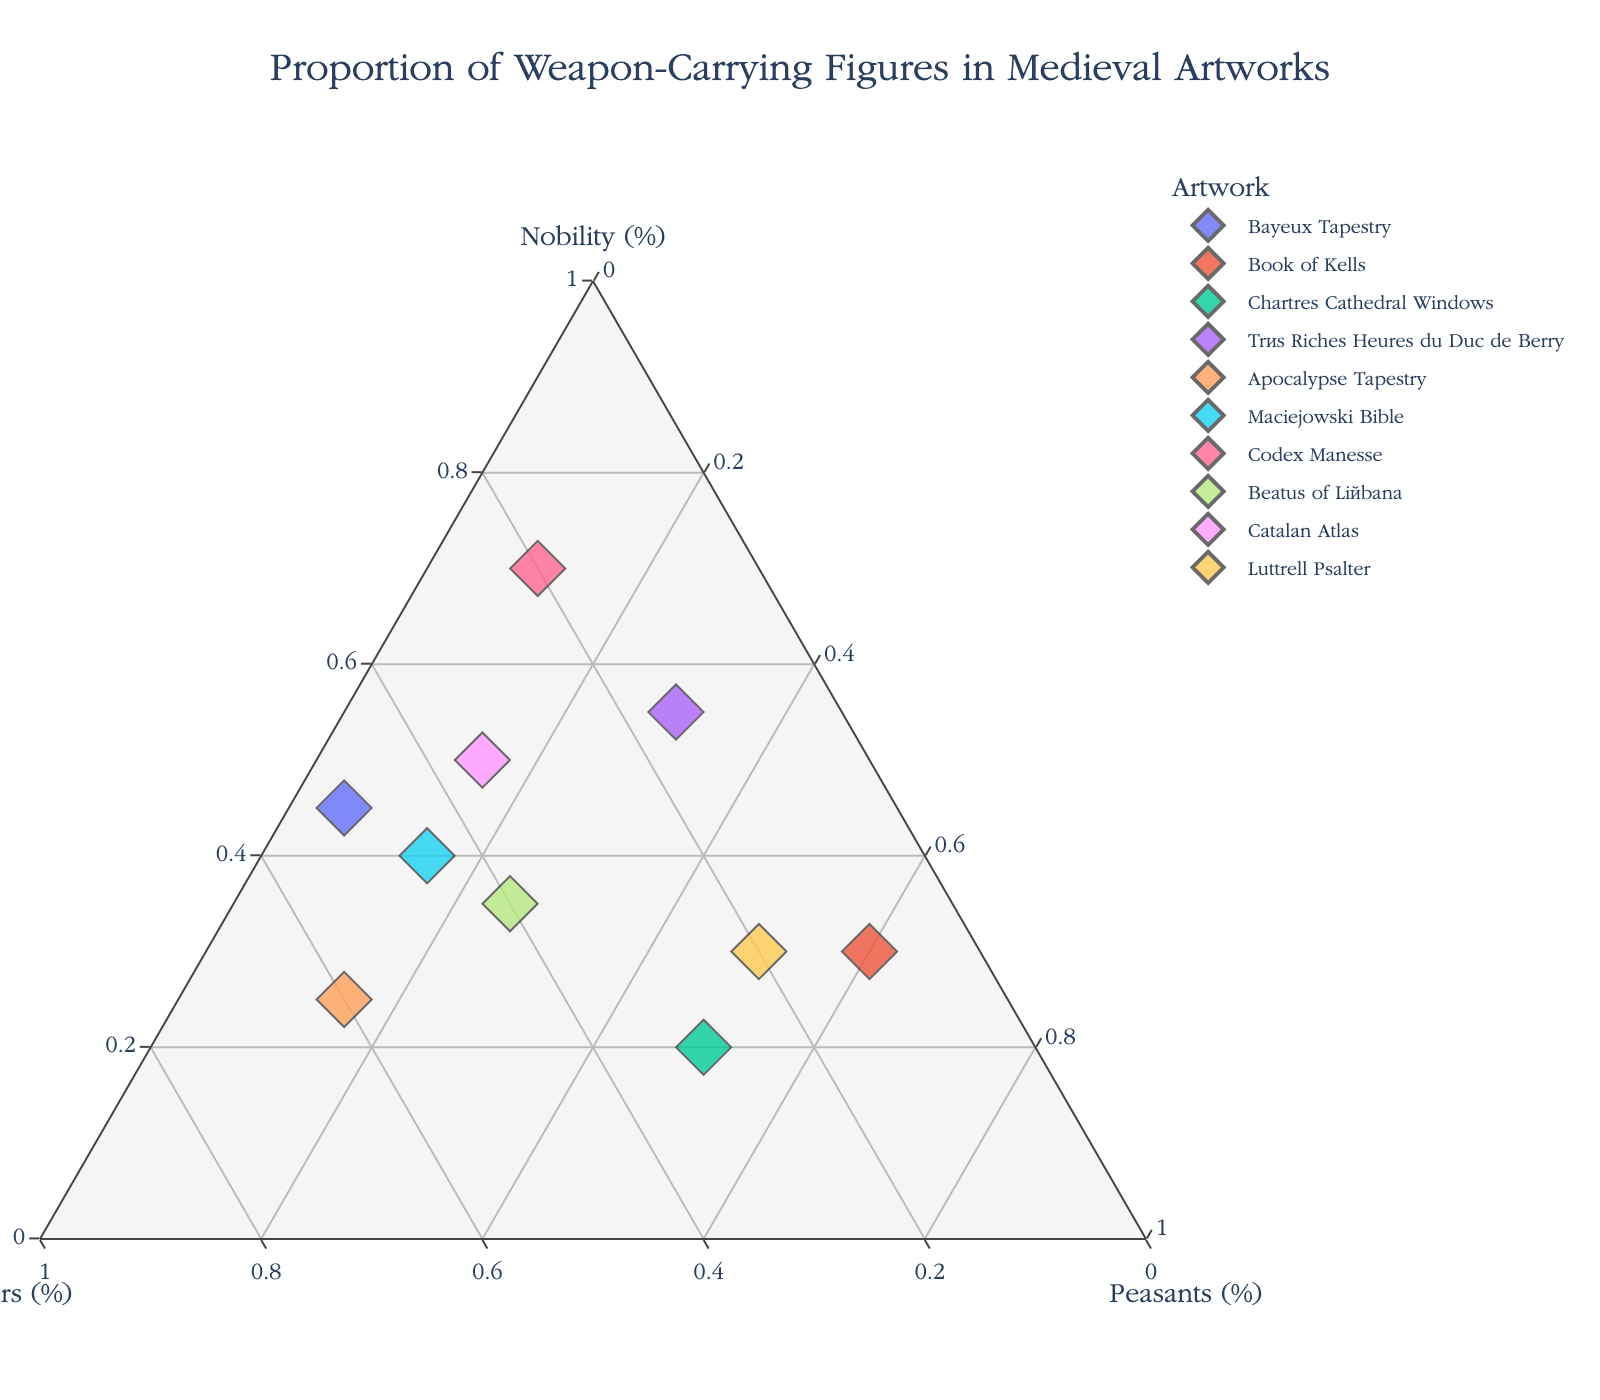what is the title of the plot? The title of the plot is typically positioned at the top center of the figure and prominently displayed in a larger font size for easy visibility.
Answer: Proportion of Weapon-Carrying Figures in Medieval Artworks How many artworks are depicted in the plot? Count the number of distinct data points or markers in the ternary plot to determine the number of artworks represented.
Answer: 10 Which artwork shows the highest proportion of Nobility carrying weapons? Look for the data point that is closest to the apex representing Nobility, which would be at the top corner of the ternary plot.
Answer: Codex Manesse Which artworks have a higher proportion of Soldiers than Nobility? Compare the positions of the data points along the border between Soldiers and Nobility. Points closer to the Soldiers apex than the Nobility apex indicate a higher proportion of Soldiers.
Answer: Bayeux Tapestry, Apocalypse Tapestry, Maciejowski Bible, Beatus of Liébana, Catalan Atlas How is the balance of weapon-carrying figures distributed in the Très Riches Heures du Duc de Berry? Identify the position of the Très Riches Heures du Duc de Berry on the ternary plot and note its coordinates in relation to Nobility, Soldiers, and Peasants.
Answer: Nobility: 0.55, Soldiers: 0.15, Peasants: 0.30 Among the given artworks, which one has the lowest proportion of Peasants carrying weapons? Find the data point closest to the apex between Nobility and Soldiers, indicating the least representation of Peasants carrying weapons.
Answer: Bayeux Tapestry What can be inferred from comparing the Catalan Atlas and the Beatus of Liébana regarding soldier representation? Compare their respective positions in relation to the Soldiers apex. The point nearer denotes a higher proportion of soldiers carrying weapons.
Answer: Catalan Atlas has more soldiers than Beatus of Liébana Which artwork has a nearly equal balance between Nobility and Peasants carrying weapons? Locate the data point positioned equidistantly between Nobility and Peasants, typically along the side of the triangle.
Answer: Luttrell Psalter Do any artworks display equal proportions of Nobility, Soldiers, and Peasants carrying weapons? Check for data points located towards the center of the ternary plot, indicating a more balanced representation across the three categories.
Answer: No artwork shows equal proportions 